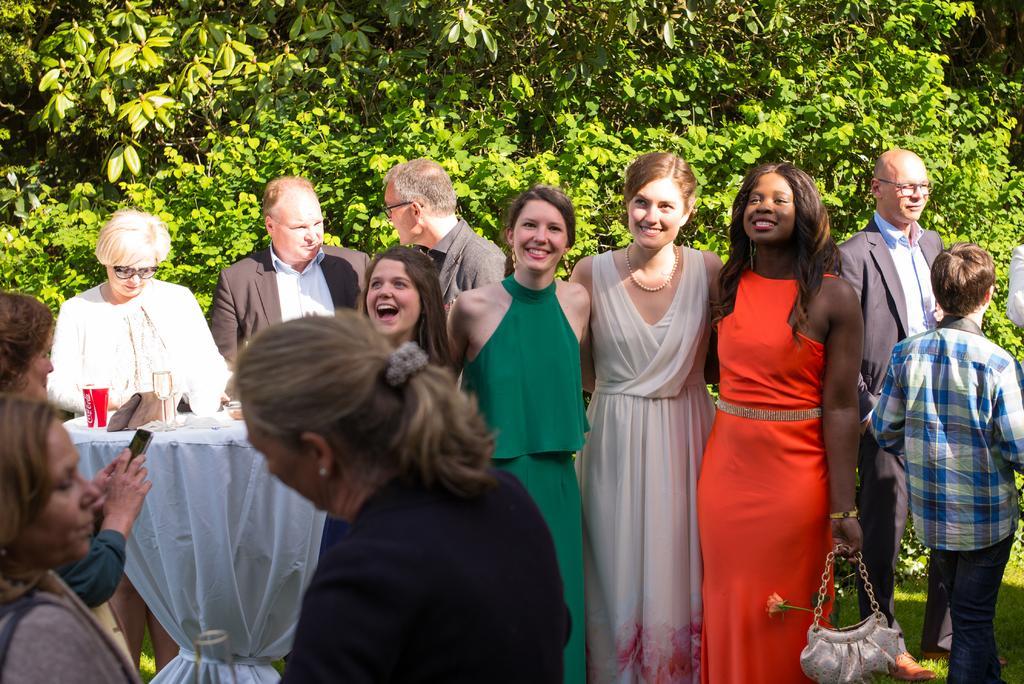Please provide a concise description of this image. As we can see in the image are group of people and trees. On the left side there is a table. On table there is white color cloth, tin and glass. The woman standing on the left side is holding a mobile phone. 